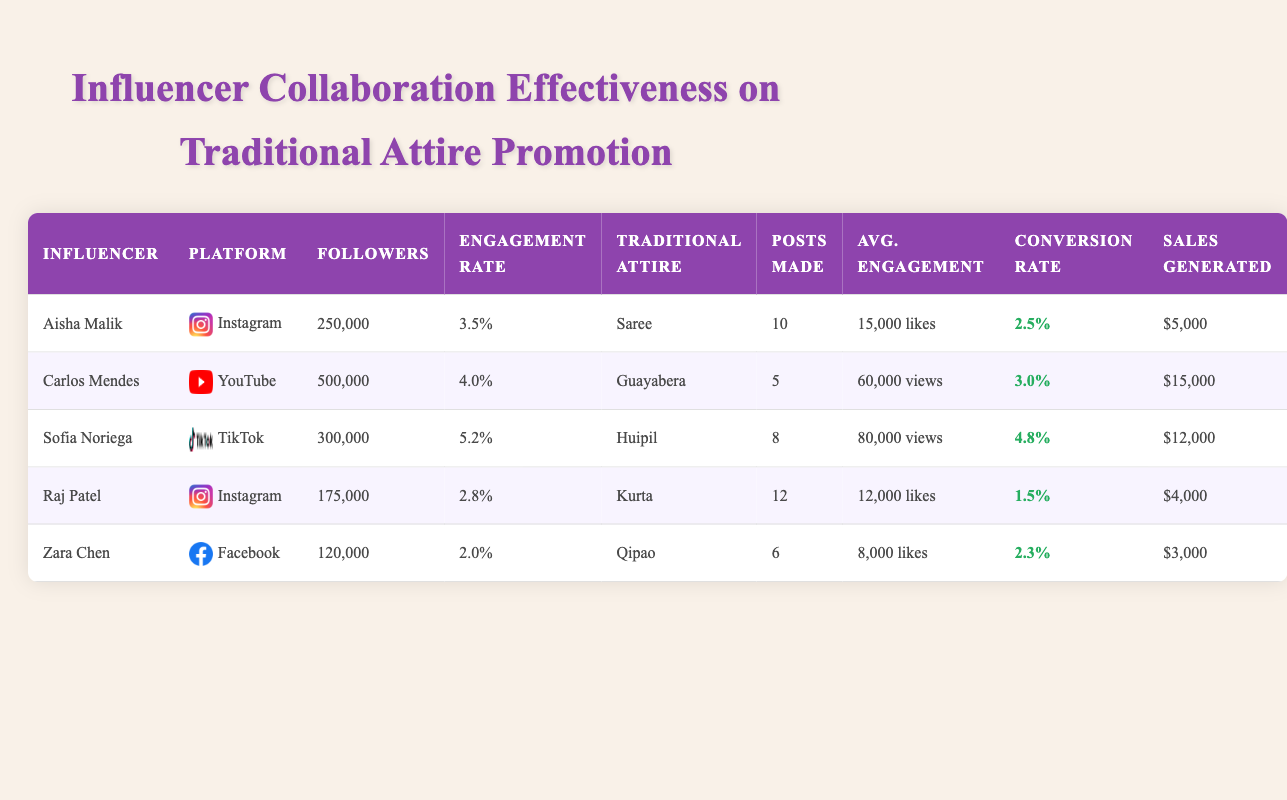How many sales were generated by Sofia Noriega? Sofia Noriega's row in the table states that she generated $12,000 in sales.
Answer: $12,000 What is the engagement rate of Carlos Mendes? Carlos Mendes' row shows an engagement rate of 4.0%.
Answer: 4.0% Which influencer had the highest conversion rate? By comparing the conversion rates in the table, Sofia Noriega has the highest rate at 4.8%.
Answer: Sofia Noriega What is the average sales generated by all influencers listed? To find the average, sum the sales figures ($5,000 + $15,000 + $12,000 + $4,000 + $3,000 = $39,000) and divide by the total number of influencers (5), resulting in an average of $39,000 / 5 = $7,800.
Answer: $7,800 Did Raj Patel generate more sales than Zara Chen? Raj Patel generated $4,000 while Zara Chen generated $3,000. $4,000 is greater than $3,000, so yes, Raj Patel generated more sales.
Answer: Yes Which traditional attire had the lowest number of posts made? By checking the posts made column, Carlos Mendes has the lowest number with only 5 posts.
Answer: Guayabera What is the total number of followers across all influencers? The total followers can be calculated by adding the individual followers from each influencer (250,000 + 500,000 + 300,000 + 175,000 + 120,000 = 1,345,000). Thus, the total is 1,345,000.
Answer: 1,345,000 Is the engagement rate of Aisha Malik higher than that of Raj Patel? Aisha Malik has an engagement rate of 3.5%, and Raj Patel's rate is 2.8%. Since 3.5% is greater than 2.8%, the answer is yes.
Answer: Yes Which influencer utilized Instagram as their platform? Looking at the table, both Aisha Malik and Raj Patel used Instagram for their promotions.
Answer: Aisha Malik and Raj Patel 